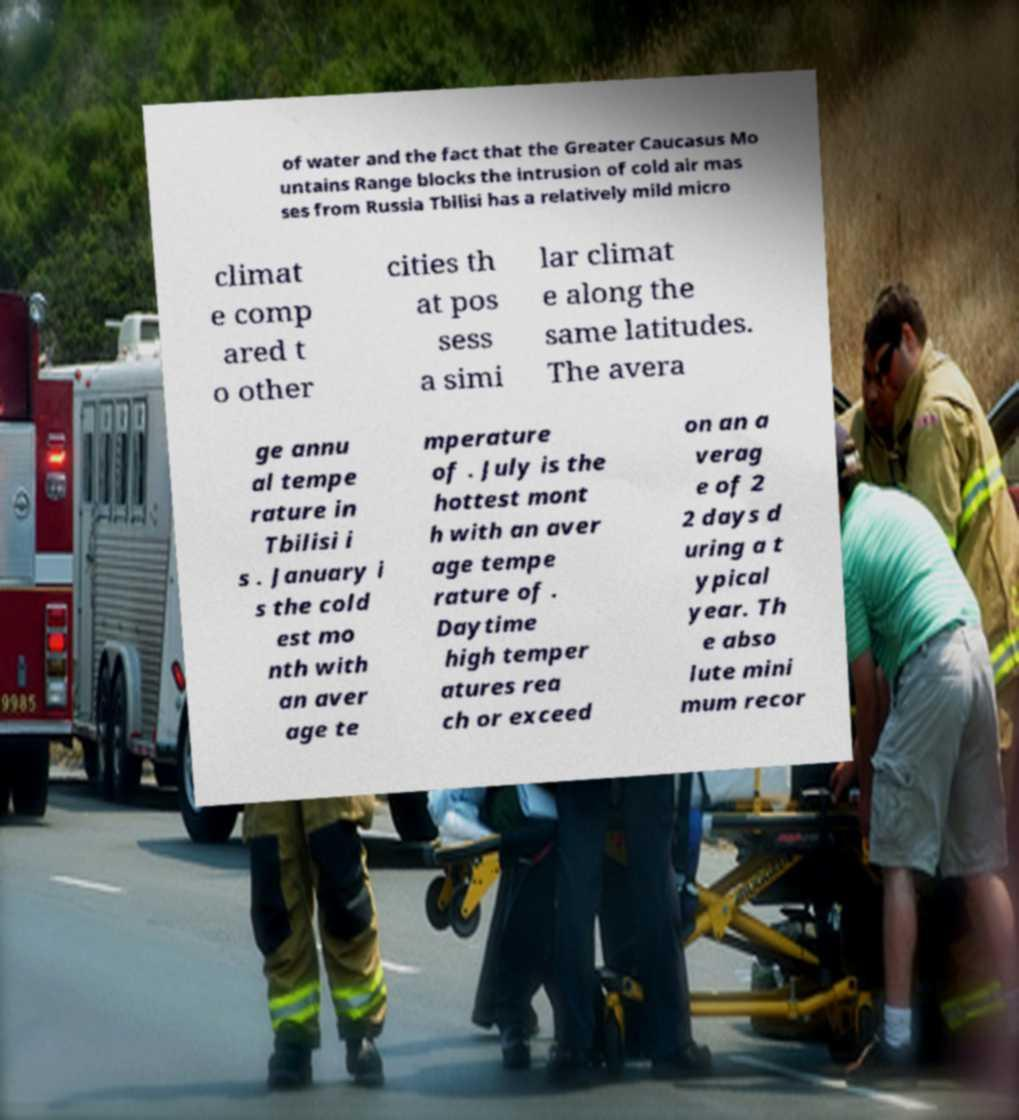Can you read and provide the text displayed in the image?This photo seems to have some interesting text. Can you extract and type it out for me? of water and the fact that the Greater Caucasus Mo untains Range blocks the intrusion of cold air mas ses from Russia Tbilisi has a relatively mild micro climat e comp ared t o other cities th at pos sess a simi lar climat e along the same latitudes. The avera ge annu al tempe rature in Tbilisi i s . January i s the cold est mo nth with an aver age te mperature of . July is the hottest mont h with an aver age tempe rature of . Daytime high temper atures rea ch or exceed on an a verag e of 2 2 days d uring a t ypical year. Th e abso lute mini mum recor 